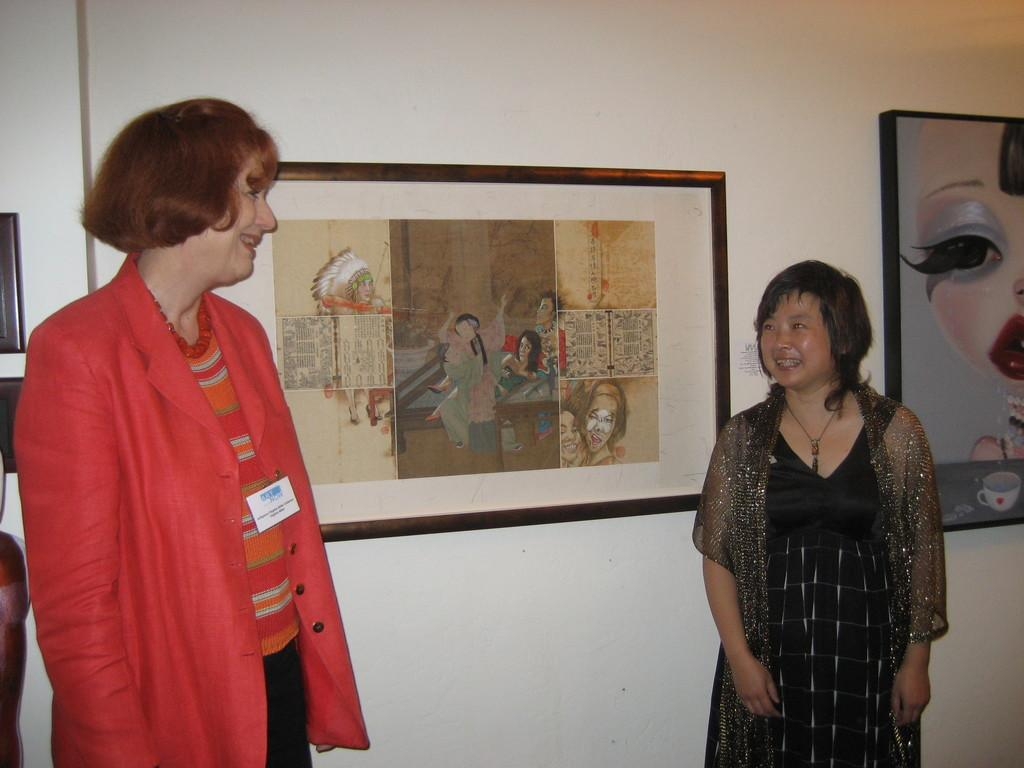How many people are in the image? There are two people in the image. What are the people wearing? The people are wearing different color dresses. What is the facial expression of the people in the image? The people are smiling. What can be seen on the wall in the background of the image? There are frames on a white wall in the background of the image. What type of food is being prepared in the image? There is no food preparation visible in the image. Can you describe the yoke that is being used by the people in the image? There is no yoke present in the image. 